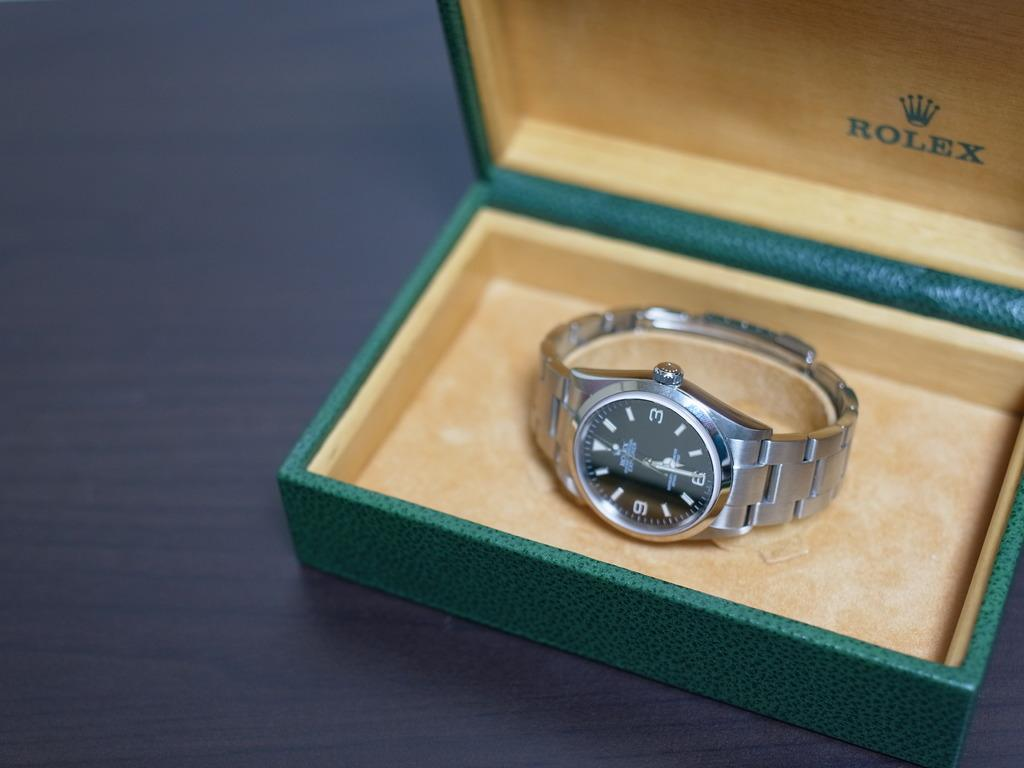Provide a one-sentence caption for the provided image. Silver and black watch inside of a Rolex box. 